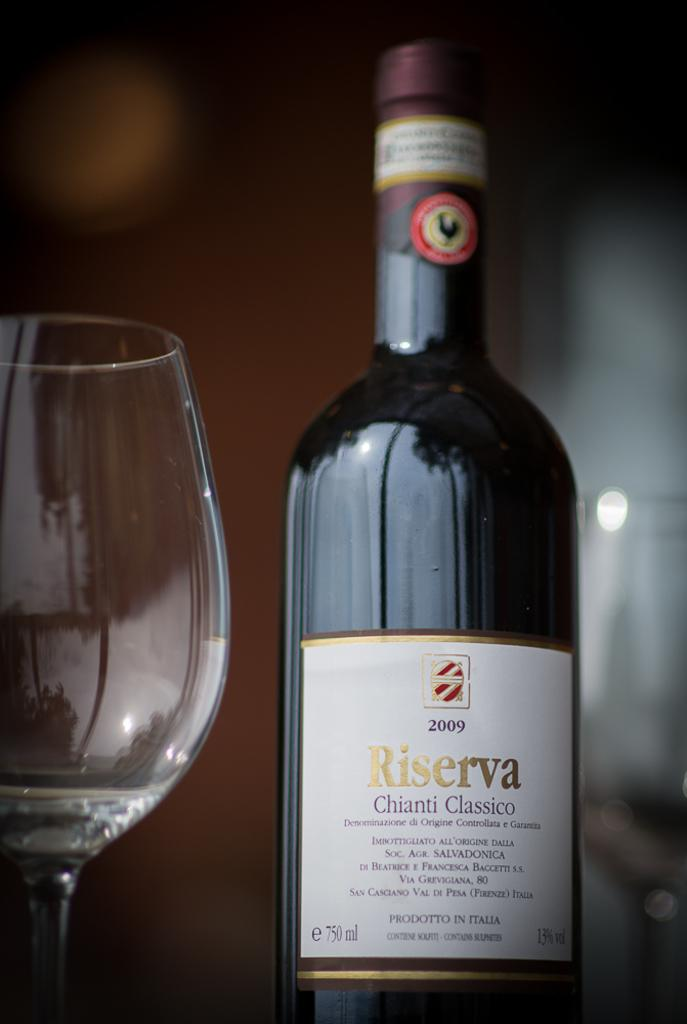<image>
Share a concise interpretation of the image provided. A 2009 bottle of Riserva sits next to en empty wine glass. 